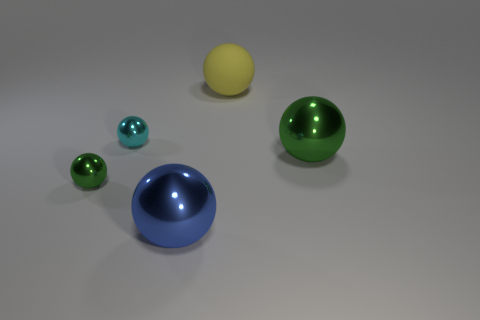Are there any cyan spheres that have the same size as the blue object? No, there are no cyan spheres that match the size of the blue hemisphere. The cyan spheres present are smaller in size relative to the blue object. 